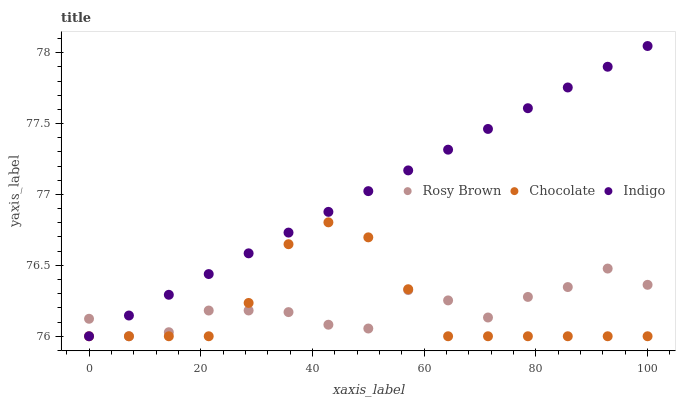Does Chocolate have the minimum area under the curve?
Answer yes or no. Yes. Does Indigo have the maximum area under the curve?
Answer yes or no. Yes. Does Indigo have the minimum area under the curve?
Answer yes or no. No. Does Chocolate have the maximum area under the curve?
Answer yes or no. No. Is Indigo the smoothest?
Answer yes or no. Yes. Is Rosy Brown the roughest?
Answer yes or no. Yes. Is Chocolate the smoothest?
Answer yes or no. No. Is Chocolate the roughest?
Answer yes or no. No. Does Rosy Brown have the lowest value?
Answer yes or no. Yes. Does Indigo have the highest value?
Answer yes or no. Yes. Does Chocolate have the highest value?
Answer yes or no. No. Does Indigo intersect Chocolate?
Answer yes or no. Yes. Is Indigo less than Chocolate?
Answer yes or no. No. Is Indigo greater than Chocolate?
Answer yes or no. No. 